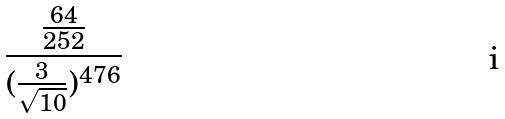Convert formula to latex. <formula><loc_0><loc_0><loc_500><loc_500>\frac { \frac { 6 4 } { 2 5 2 } } { ( \frac { 3 } { \sqrt { 1 0 } } ) ^ { 4 7 6 } }</formula> 